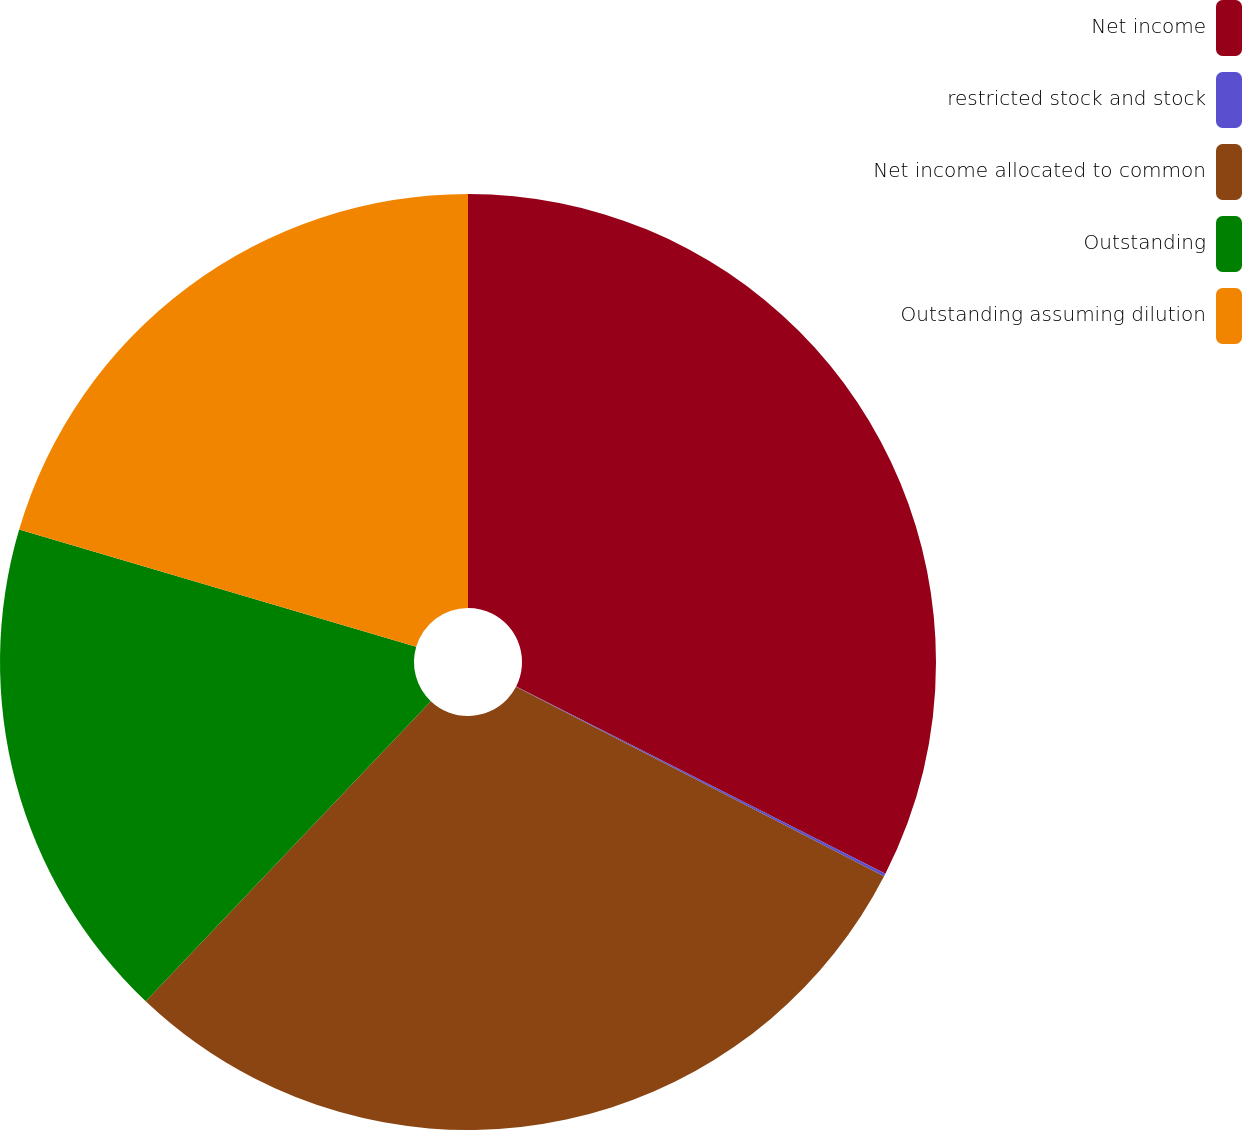<chart> <loc_0><loc_0><loc_500><loc_500><pie_chart><fcel>Net income<fcel>restricted stock and stock<fcel>Net income allocated to common<fcel>Outstanding<fcel>Outstanding assuming dilution<nl><fcel>32.47%<fcel>0.1%<fcel>29.52%<fcel>17.48%<fcel>20.43%<nl></chart> 